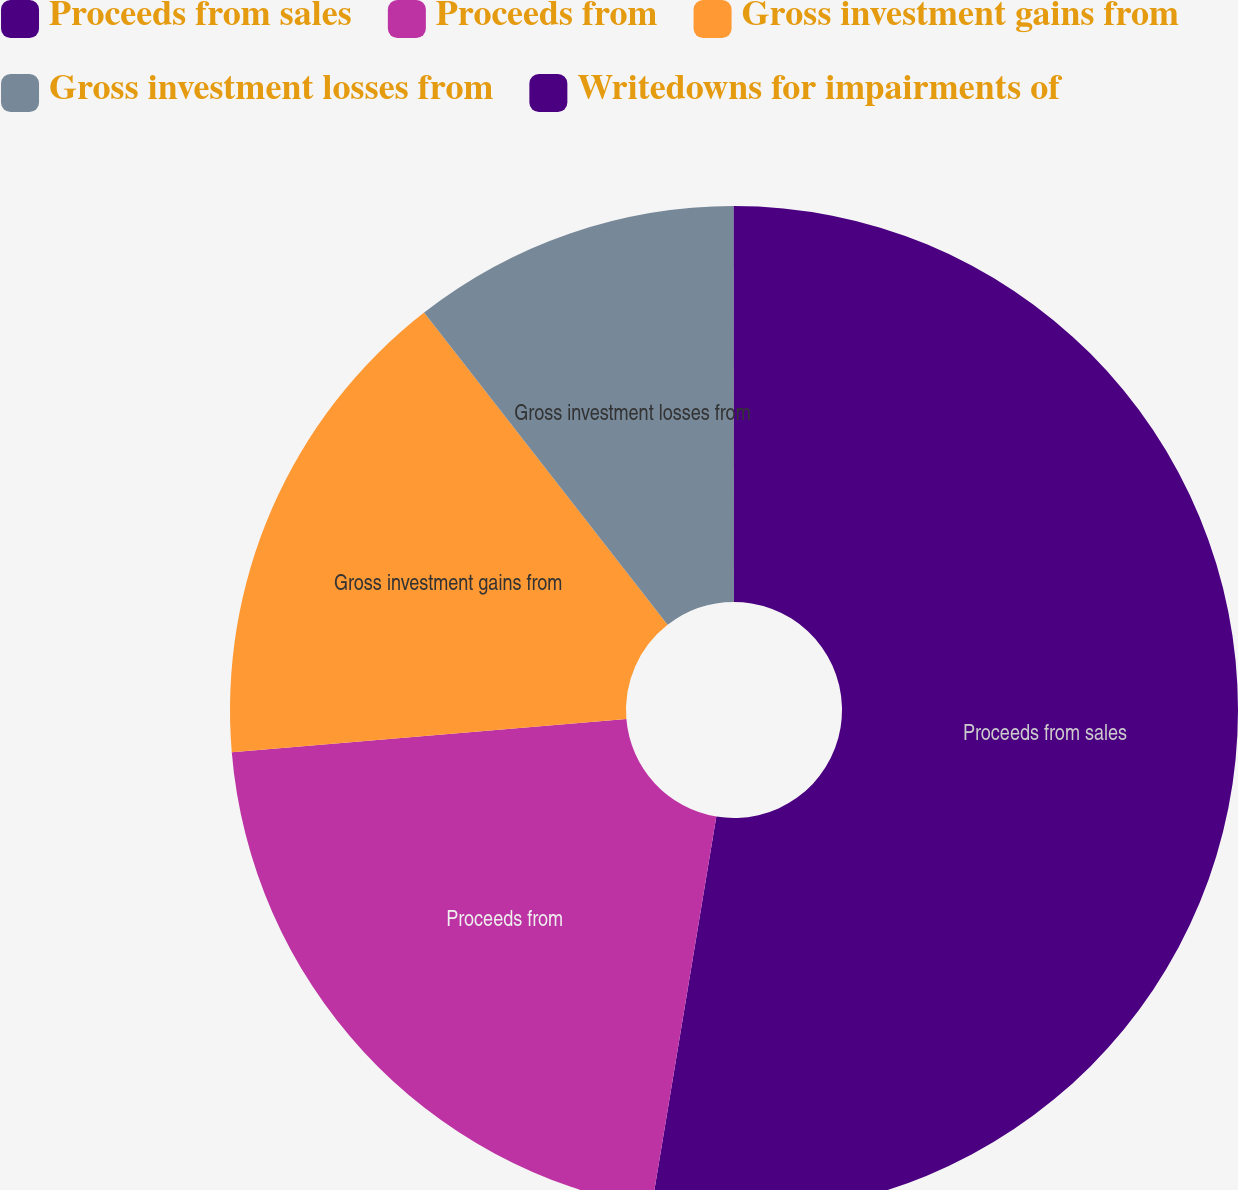Convert chart. <chart><loc_0><loc_0><loc_500><loc_500><pie_chart><fcel>Proceeds from sales<fcel>Proceeds from<fcel>Gross investment gains from<fcel>Gross investment losses from<fcel>Writedowns for impairments of<nl><fcel>52.61%<fcel>21.05%<fcel>15.79%<fcel>10.53%<fcel>0.01%<nl></chart> 